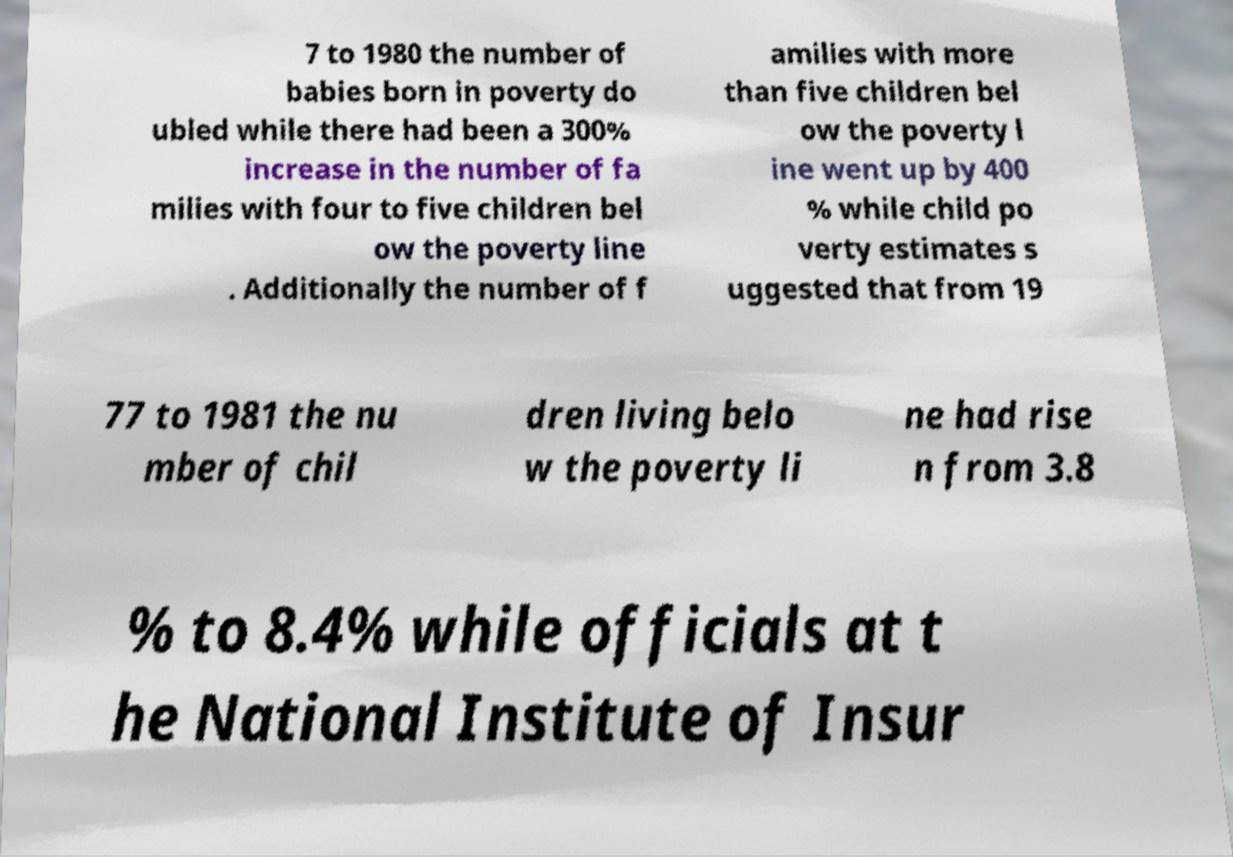Can you accurately transcribe the text from the provided image for me? 7 to 1980 the number of babies born in poverty do ubled while there had been a 300% increase in the number of fa milies with four to five children bel ow the poverty line . Additionally the number of f amilies with more than five children bel ow the poverty l ine went up by 400 % while child po verty estimates s uggested that from 19 77 to 1981 the nu mber of chil dren living belo w the poverty li ne had rise n from 3.8 % to 8.4% while officials at t he National Institute of Insur 